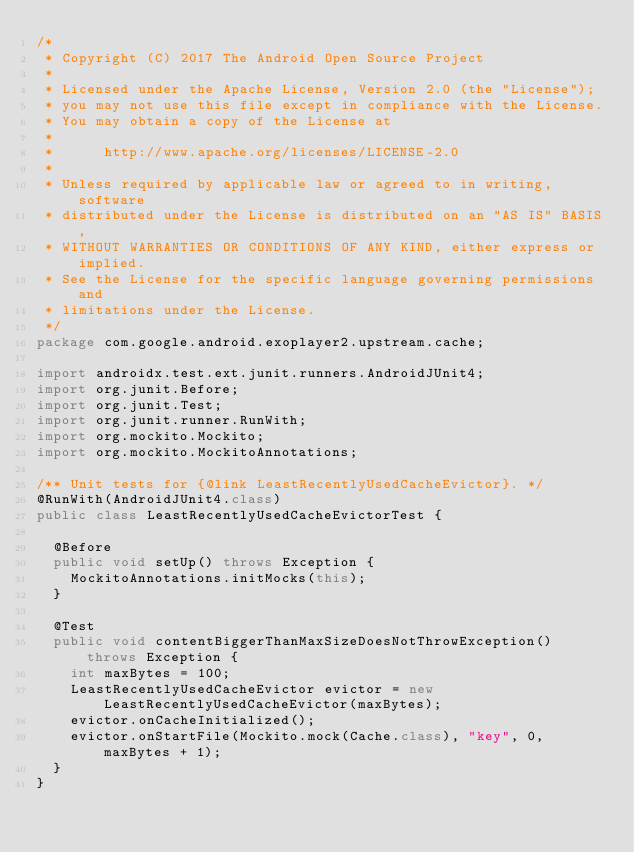<code> <loc_0><loc_0><loc_500><loc_500><_Java_>/*
 * Copyright (C) 2017 The Android Open Source Project
 *
 * Licensed under the Apache License, Version 2.0 (the "License");
 * you may not use this file except in compliance with the License.
 * You may obtain a copy of the License at
 *
 *      http://www.apache.org/licenses/LICENSE-2.0
 *
 * Unless required by applicable law or agreed to in writing, software
 * distributed under the License is distributed on an "AS IS" BASIS,
 * WITHOUT WARRANTIES OR CONDITIONS OF ANY KIND, either express or implied.
 * See the License for the specific language governing permissions and
 * limitations under the License.
 */
package com.google.android.exoplayer2.upstream.cache;

import androidx.test.ext.junit.runners.AndroidJUnit4;
import org.junit.Before;
import org.junit.Test;
import org.junit.runner.RunWith;
import org.mockito.Mockito;
import org.mockito.MockitoAnnotations;

/** Unit tests for {@link LeastRecentlyUsedCacheEvictor}. */
@RunWith(AndroidJUnit4.class)
public class LeastRecentlyUsedCacheEvictorTest {

  @Before
  public void setUp() throws Exception {
    MockitoAnnotations.initMocks(this);
  }

  @Test
  public void contentBiggerThanMaxSizeDoesNotThrowException() throws Exception {
    int maxBytes = 100;
    LeastRecentlyUsedCacheEvictor evictor = new LeastRecentlyUsedCacheEvictor(maxBytes);
    evictor.onCacheInitialized();
    evictor.onStartFile(Mockito.mock(Cache.class), "key", 0, maxBytes + 1);
  }
}
</code> 